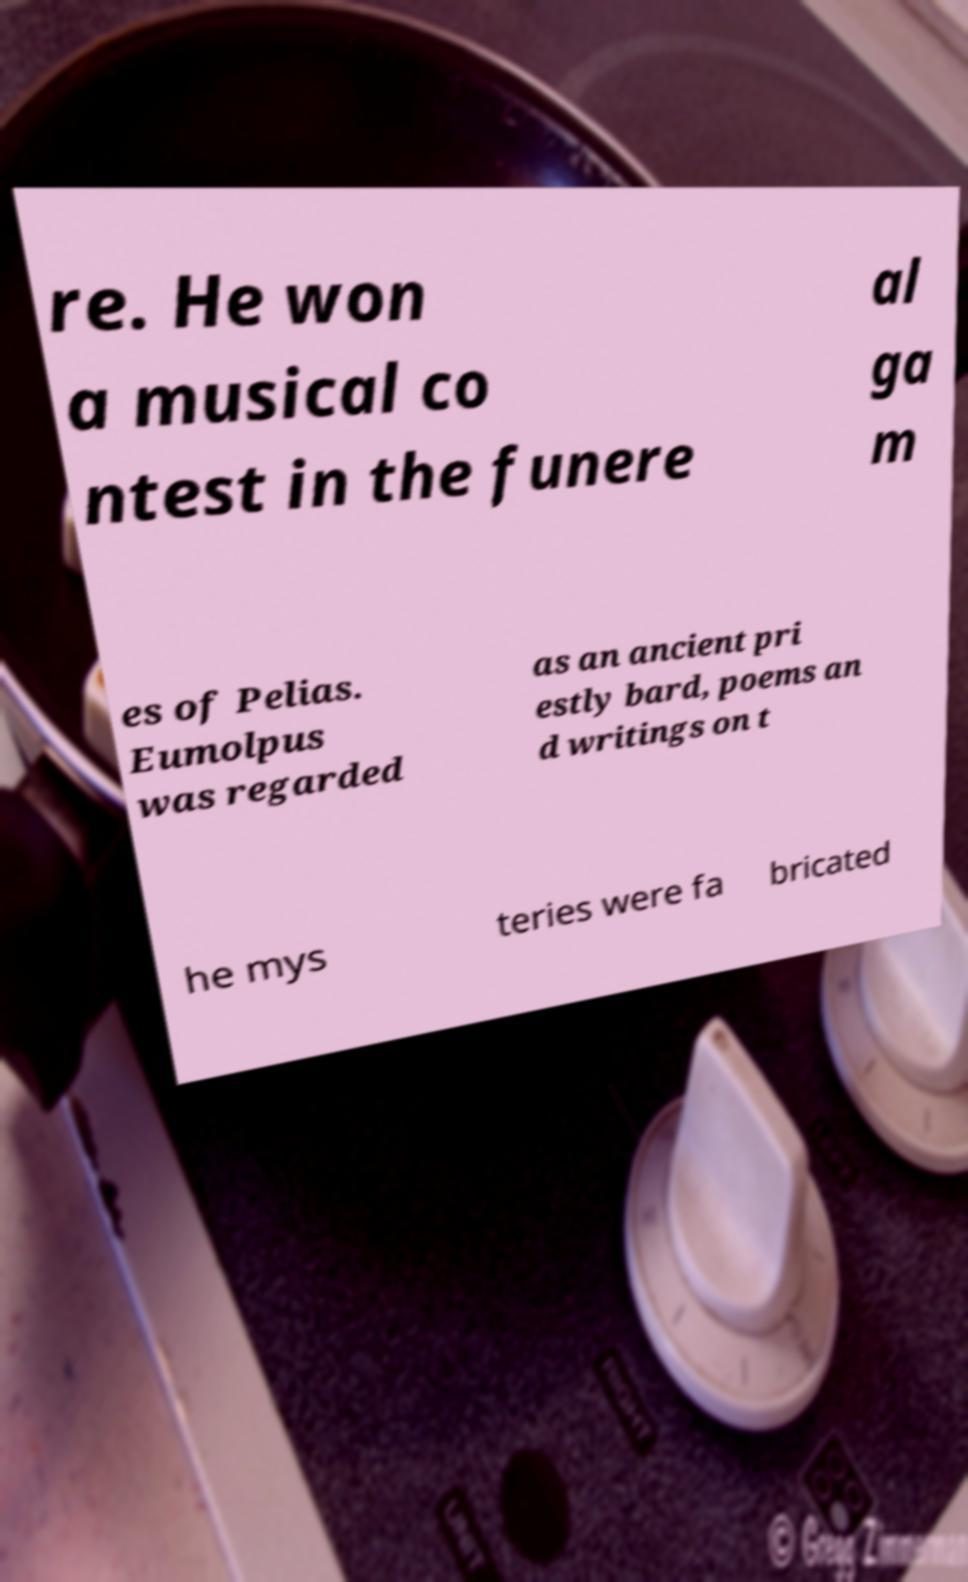There's text embedded in this image that I need extracted. Can you transcribe it verbatim? re. He won a musical co ntest in the funere al ga m es of Pelias. Eumolpus was regarded as an ancient pri estly bard, poems an d writings on t he mys teries were fa bricated 